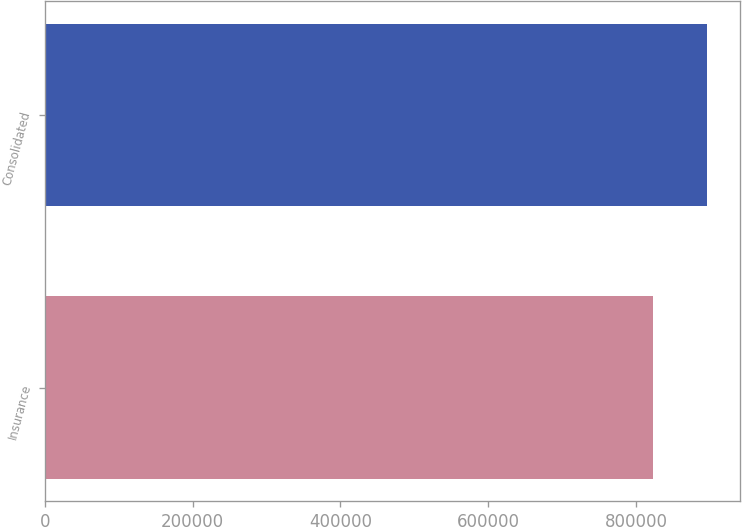Convert chart. <chart><loc_0><loc_0><loc_500><loc_500><bar_chart><fcel>Insurance<fcel>Consolidated<nl><fcel>822617<fcel>896438<nl></chart> 